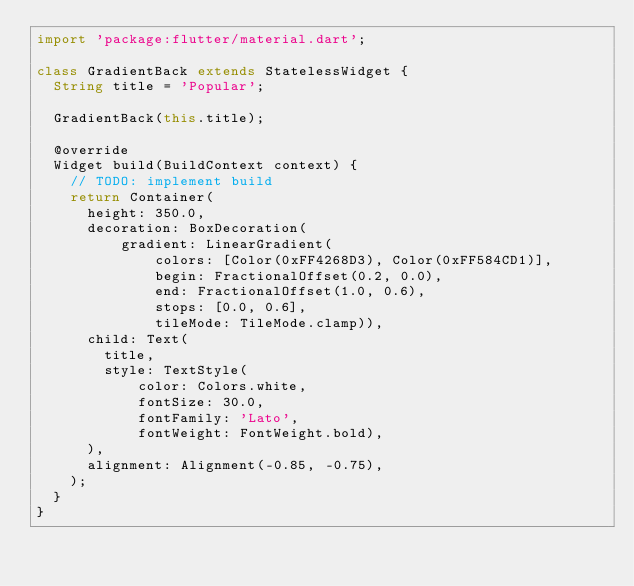Convert code to text. <code><loc_0><loc_0><loc_500><loc_500><_Dart_>import 'package:flutter/material.dart';

class GradientBack extends StatelessWidget {
  String title = 'Popular';

  GradientBack(this.title);

  @override
  Widget build(BuildContext context) {
    // TODO: implement build
    return Container(
      height: 350.0,
      decoration: BoxDecoration(
          gradient: LinearGradient(
              colors: [Color(0xFF4268D3), Color(0xFF584CD1)],
              begin: FractionalOffset(0.2, 0.0),
              end: FractionalOffset(1.0, 0.6),
              stops: [0.0, 0.6],
              tileMode: TileMode.clamp)),
      child: Text(
        title,
        style: TextStyle(
            color: Colors.white,
            fontSize: 30.0,
            fontFamily: 'Lato',
            fontWeight: FontWeight.bold),
      ),
      alignment: Alignment(-0.85, -0.75),
    );
  }
}
</code> 